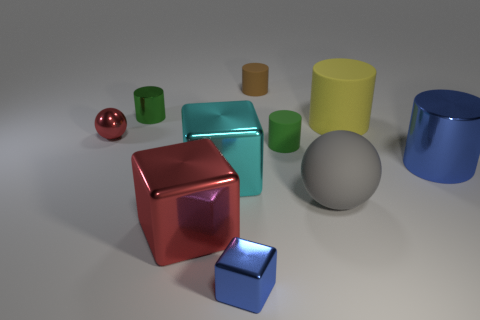What color is the tiny matte cylinder that is behind the green cylinder in front of the metallic cylinder on the left side of the large cyan thing? The color of the tiny matte cylinder that is situated behind the green cylinder and in front of the metallic cylinder to the left of the large cyan object is brown. It partially blends into the background, but its matte texture differentiates it from the surrounding glossy surfaces. 